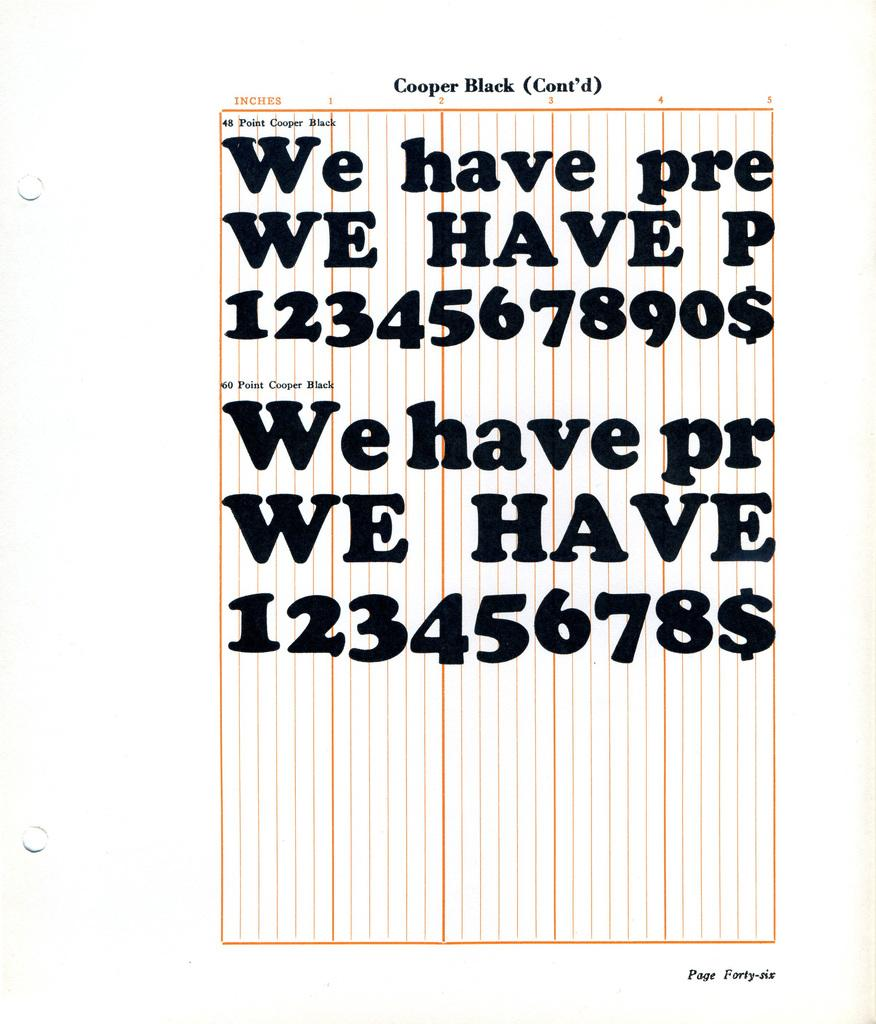<image>
Give a short and clear explanation of the subsequent image. Black writing is on top of colored lines on page forty-six of Cooper Black. 